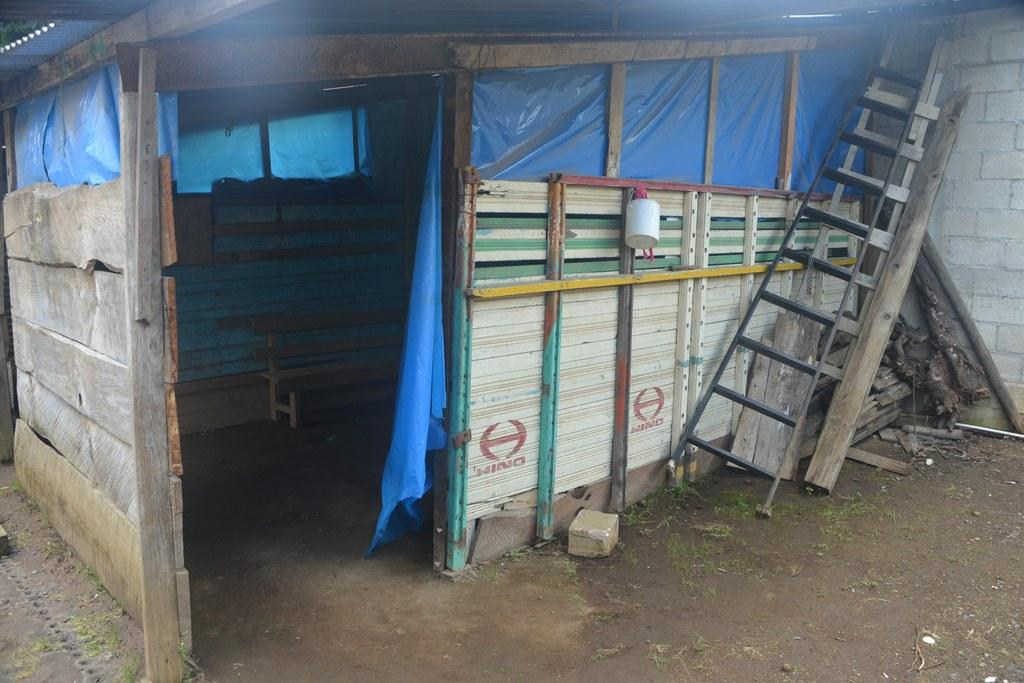What type of structure is present in the image? There is a small hut in the image. What can be found inside the hut? Inside the hut, there is a bench. What are the ladders used for in the image? The ladders are kept outside the hut, possibly for climbing or accessing higher areas. How does the hut express shame in the image? The hut does not express shame in the image, as it is an inanimate object and cannot experience emotions. 